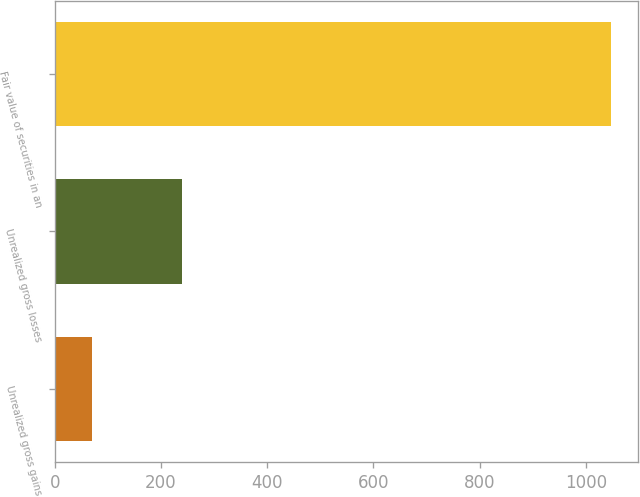<chart> <loc_0><loc_0><loc_500><loc_500><bar_chart><fcel>Unrealized gross gains<fcel>Unrealized gross losses<fcel>Fair value of securities in an<nl><fcel>69.9<fcel>239<fcel>1046.1<nl></chart> 